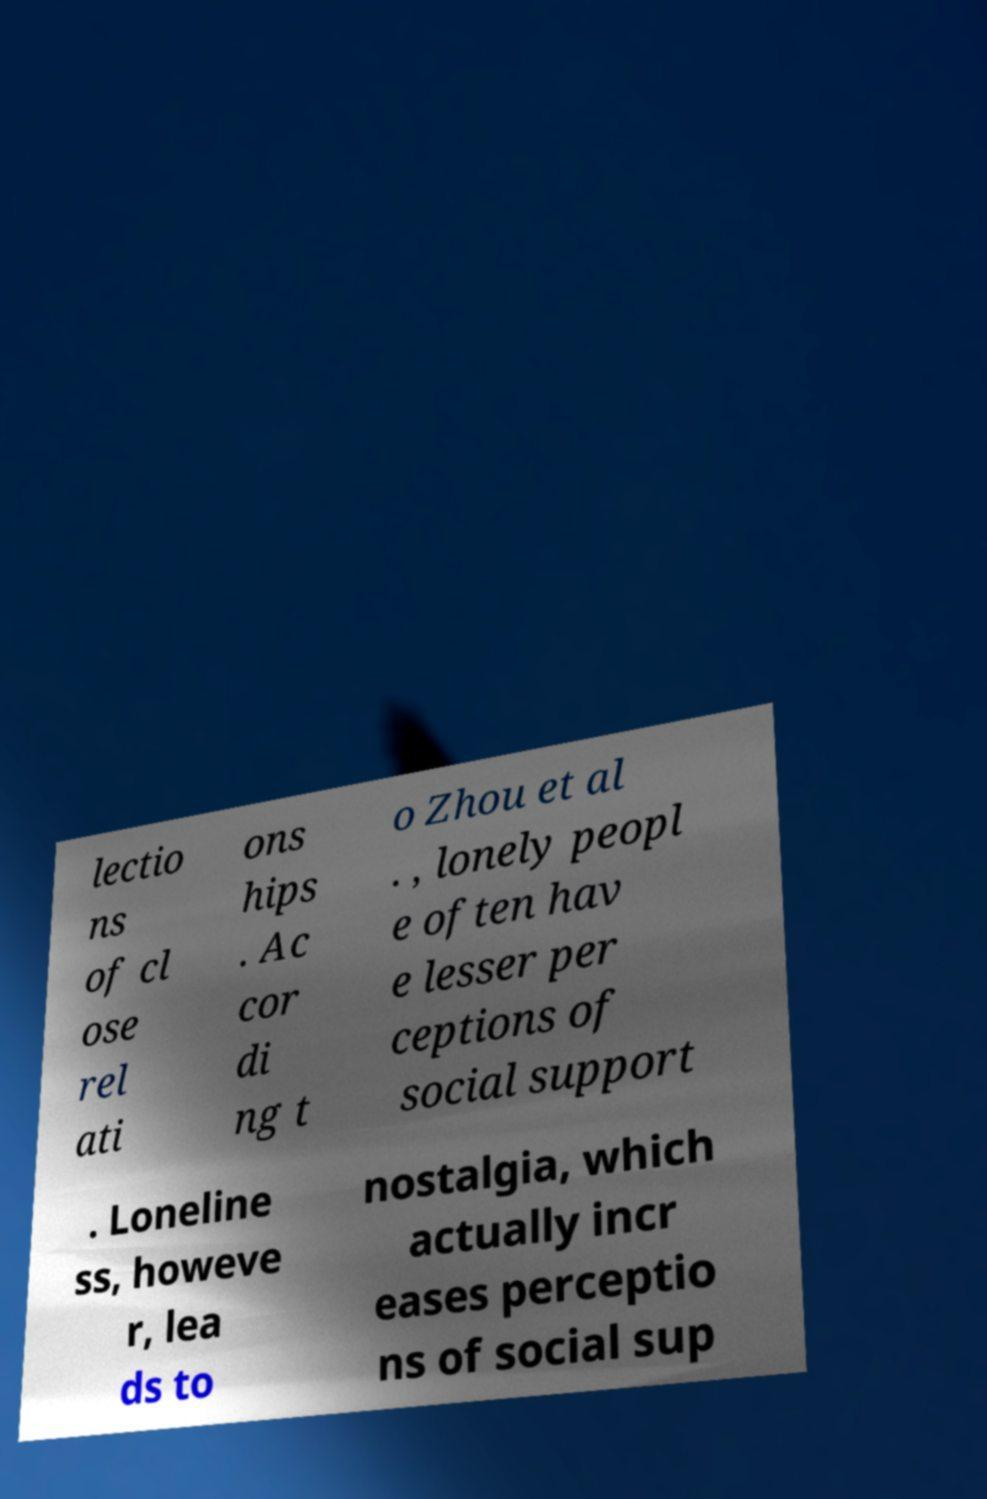Please read and relay the text visible in this image. What does it say? lectio ns of cl ose rel ati ons hips . Ac cor di ng t o Zhou et al . , lonely peopl e often hav e lesser per ceptions of social support . Loneline ss, howeve r, lea ds to nostalgia, which actually incr eases perceptio ns of social sup 